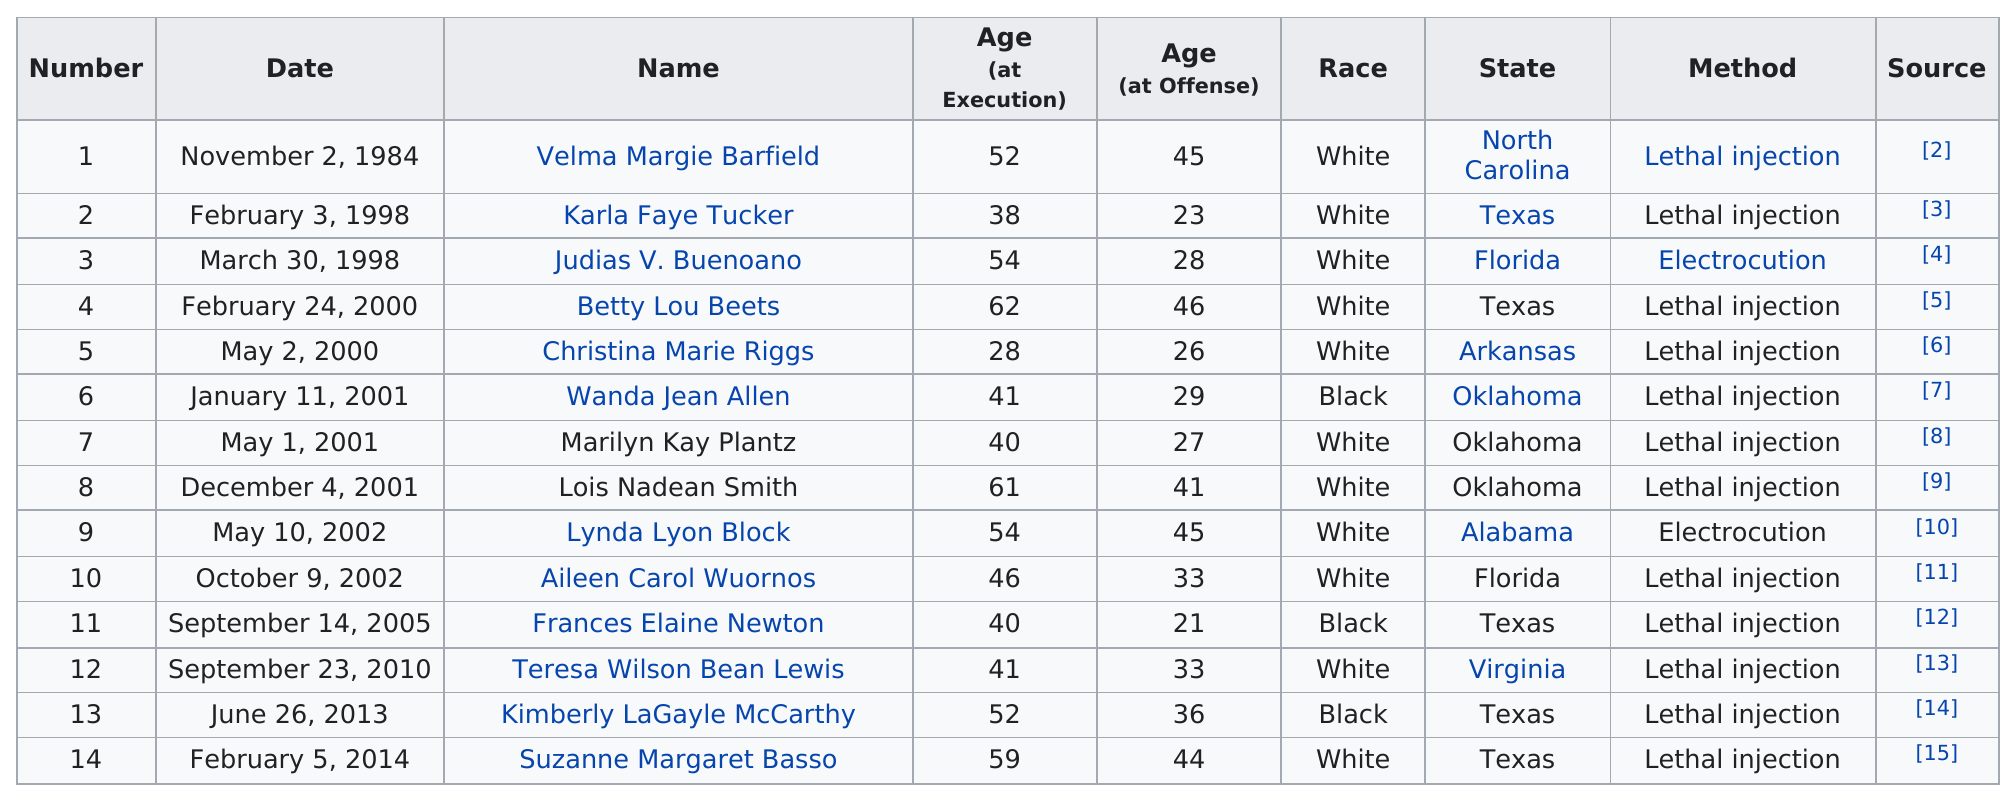Give some essential details in this illustration. The total number of women executed between 2000 and 2010 is 9. Since 1976, 12 women have been executed by lethal injection. Aileen Carol Wuornos was the next consecutive woman to be executed after Lynda Lyon Block. Lois Nadean Smith was executed in the same year as Marilyn Kay Plantz and Wanda Jean Allen, who were both women. The number of women executed in Oklahoma is 3. 